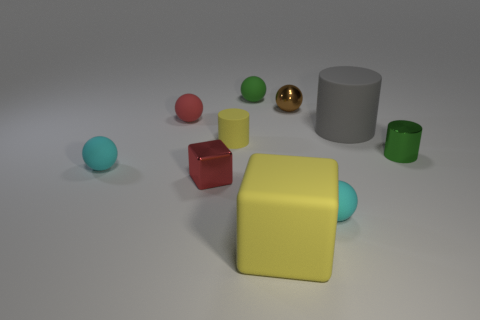Subtract all gray cylinders. How many cyan balls are left? 2 Subtract 1 balls. How many balls are left? 4 Subtract all green spheres. How many spheres are left? 4 Subtract all tiny cylinders. How many cylinders are left? 1 Subtract all brown spheres. Subtract all gray cubes. How many spheres are left? 4 Subtract all cylinders. How many objects are left? 7 Add 8 red metal objects. How many red metal objects exist? 9 Subtract 1 yellow blocks. How many objects are left? 9 Subtract all big green shiny cylinders. Subtract all tiny matte objects. How many objects are left? 5 Add 7 tiny yellow objects. How many tiny yellow objects are left? 8 